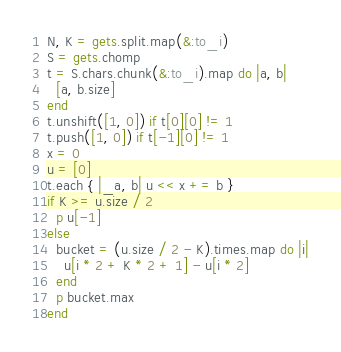Convert code to text. <code><loc_0><loc_0><loc_500><loc_500><_Ruby_>N, K = gets.split.map(&:to_i)
S = gets.chomp
t = S.chars.chunk(&:to_i).map do |a, b|
  [a, b.size]
end
t.unshift([1, 0]) if t[0][0] != 1
t.push([1, 0]) if t[-1][0] != 1
x = 0
u = [0]
t.each { |_a, b| u << x += b }
if K >= u.size / 2
  p u[-1]
else
  bucket = (u.size / 2 - K).times.map do |i|
    u[i * 2 + K * 2 + 1] - u[i * 2]
  end
  p bucket.max
end
</code> 